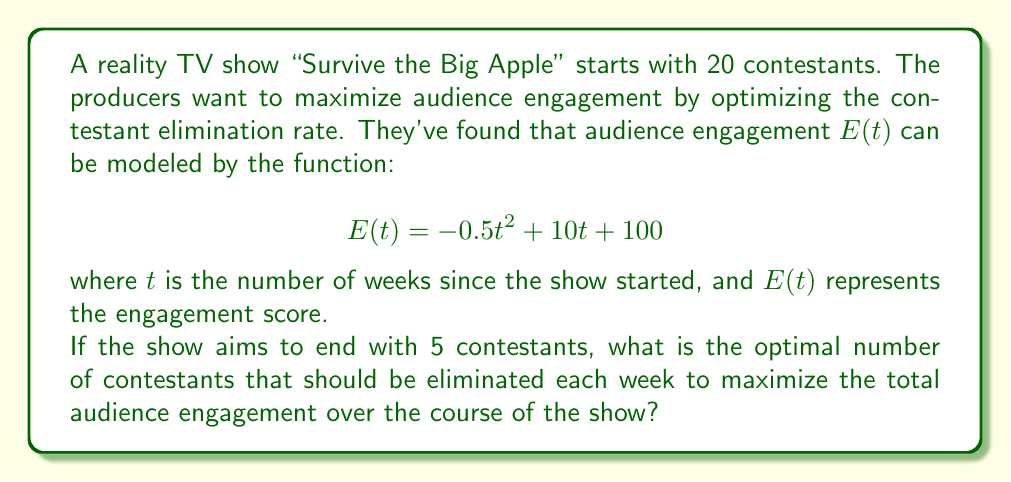Show me your answer to this math problem. Let's approach this step-by-step:

1) First, we need to determine how many contestants need to be eliminated in total:
   20 (initial) - 5 (final) = 15 contestants to be eliminated

2) Let $x$ be the number of contestants eliminated each week. Then, the number of weeks the show will run is:
   $\frac{15}{x}$

3) To find the total engagement over the course of the show, we need to integrate $E(t)$ from 0 to $\frac{15}{x}$:

   $$\int_0^{\frac{15}{x}} (-0.5t^2 + 10t + 100) dt$$

4) Solving this integral:

   $$\left[-\frac{1}{6}t^3 + 5t^2 + 100t\right]_0^{\frac{15}{x}}$$

   $$= \left(-\frac{1}{6}\left(\frac{15}{x}\right)^3 + 5\left(\frac{15}{x}\right)^2 + 100\left(\frac{15}{x}\right)\right) - 0$$

   $$= -\frac{3375}{6x^3} + \frac{1125}{x^2} + \frac{1500}{x}$$

5) To maximize this function, we need to find where its derivative equals zero:

   $$\frac{d}{dx}\left(-\frac{3375}{6x^3} + \frac{1125}{x^2} + \frac{1500}{x}\right) = \frac{3375}{2x^4} - \frac{2250}{x^3} - \frac{1500}{x^2} = 0$$

6) Multiplying both sides by $x^4$:

   $$1687.5 - 2250x + 1500x^2 = 0$$

7) Solving this quadratic equation:

   $$x = \frac{2250 \pm \sqrt{2250^2 - 4(1500)(1687.5)}}{2(1500)}$$

   $$x \approx 1.5 \text{ or } 0.75$$

8) Since we can't eliminate fractional contestants, we round to the nearest whole number. 0.75 rounds to 1, and 1.5 rounds to 2.

9) To determine which is better, we can plug both values back into our total engagement function from step 4:

   For x = 1: 1743.75
   For x = 2: 1546.875

Therefore, eliminating 1 contestant per week yields higher total engagement.
Answer: The optimal number of contestants to eliminate each week is 1. 